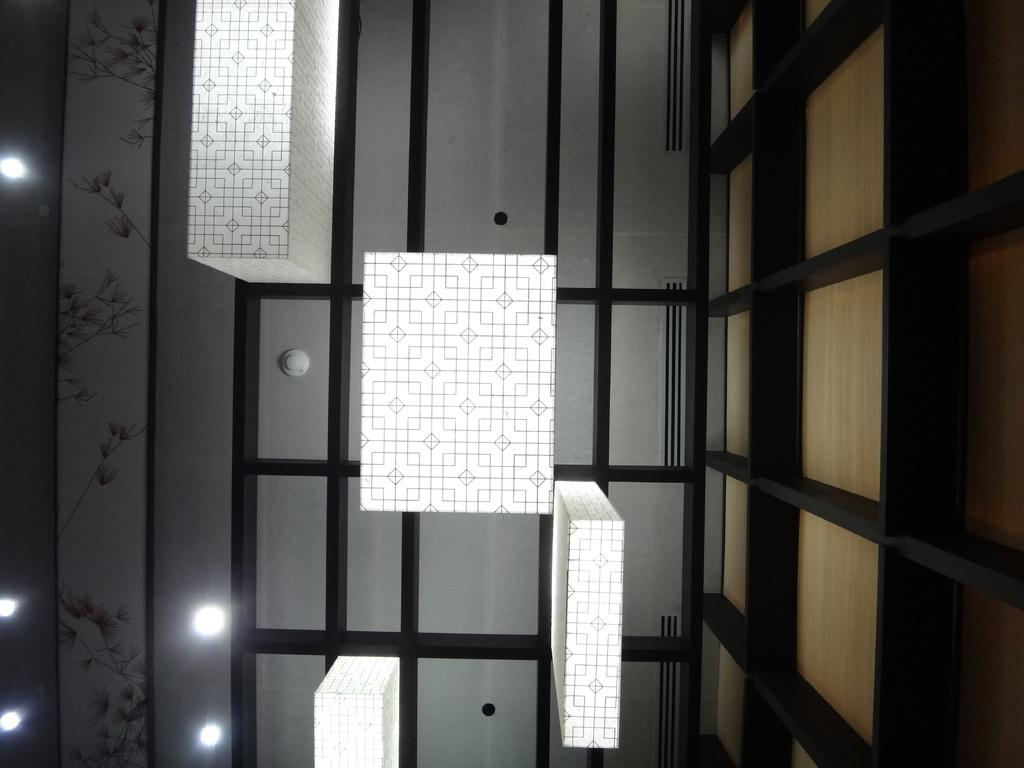Where was the image taken? The image was taken inside a room. What can be seen on the wall in the image? There are lights on the wall in the image. What shapes are present in the rectangular structures in the image? The rectangular structures in the image have rectangular shapes. What type of process is being carried out in the room in the image? There is no indication of a process being carried out in the room in the image. Can you see any dust particles in the image? There is no mention of dust particles in the image, and they are not visible in the provided facts. 